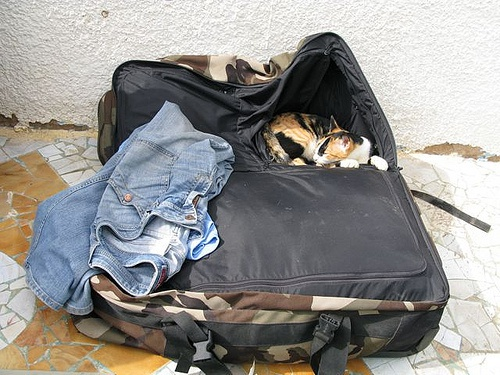Describe the objects in this image and their specific colors. I can see suitcase in darkgray, gray, black, and ivory tones, backpack in darkgray, gray, black, and ivory tones, and cat in darkgray, black, ivory, tan, and gray tones in this image. 